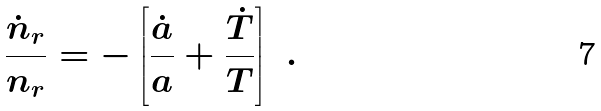Convert formula to latex. <formula><loc_0><loc_0><loc_500><loc_500>\frac { \dot { n } _ { r } } { n _ { r } } = - \left [ \frac { \dot { a } } { a } + \frac { \dot { T } } { T } \right ] \ .</formula> 